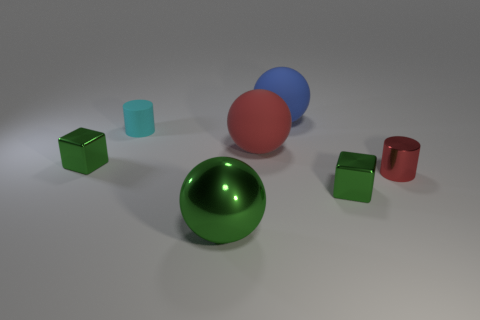The big thing in front of the small green thing that is on the left side of the big blue object is what color?
Your response must be concise. Green. What shape is the tiny green metal thing that is to the right of the matte ball behind the matte thing left of the green sphere?
Offer a very short reply. Cube. There is a matte thing that is to the right of the big green sphere and in front of the blue rubber ball; how big is it?
Ensure brevity in your answer.  Large. What number of large shiny balls are the same color as the metal cylinder?
Your answer should be very brief. 0. There is a big sphere that is the same color as the metallic cylinder; what is its material?
Your response must be concise. Rubber. What is the material of the green ball?
Make the answer very short. Metal. Do the cylinder to the right of the tiny cyan rubber cylinder and the large red thing have the same material?
Ensure brevity in your answer.  No. There is a tiny thing that is on the left side of the cyan thing; what is its shape?
Your answer should be very brief. Cube. What material is the cylinder that is the same size as the cyan rubber thing?
Keep it short and to the point. Metal. What number of things are either small cyan cylinders to the left of the blue thing or large rubber things in front of the small cyan cylinder?
Make the answer very short. 2. 